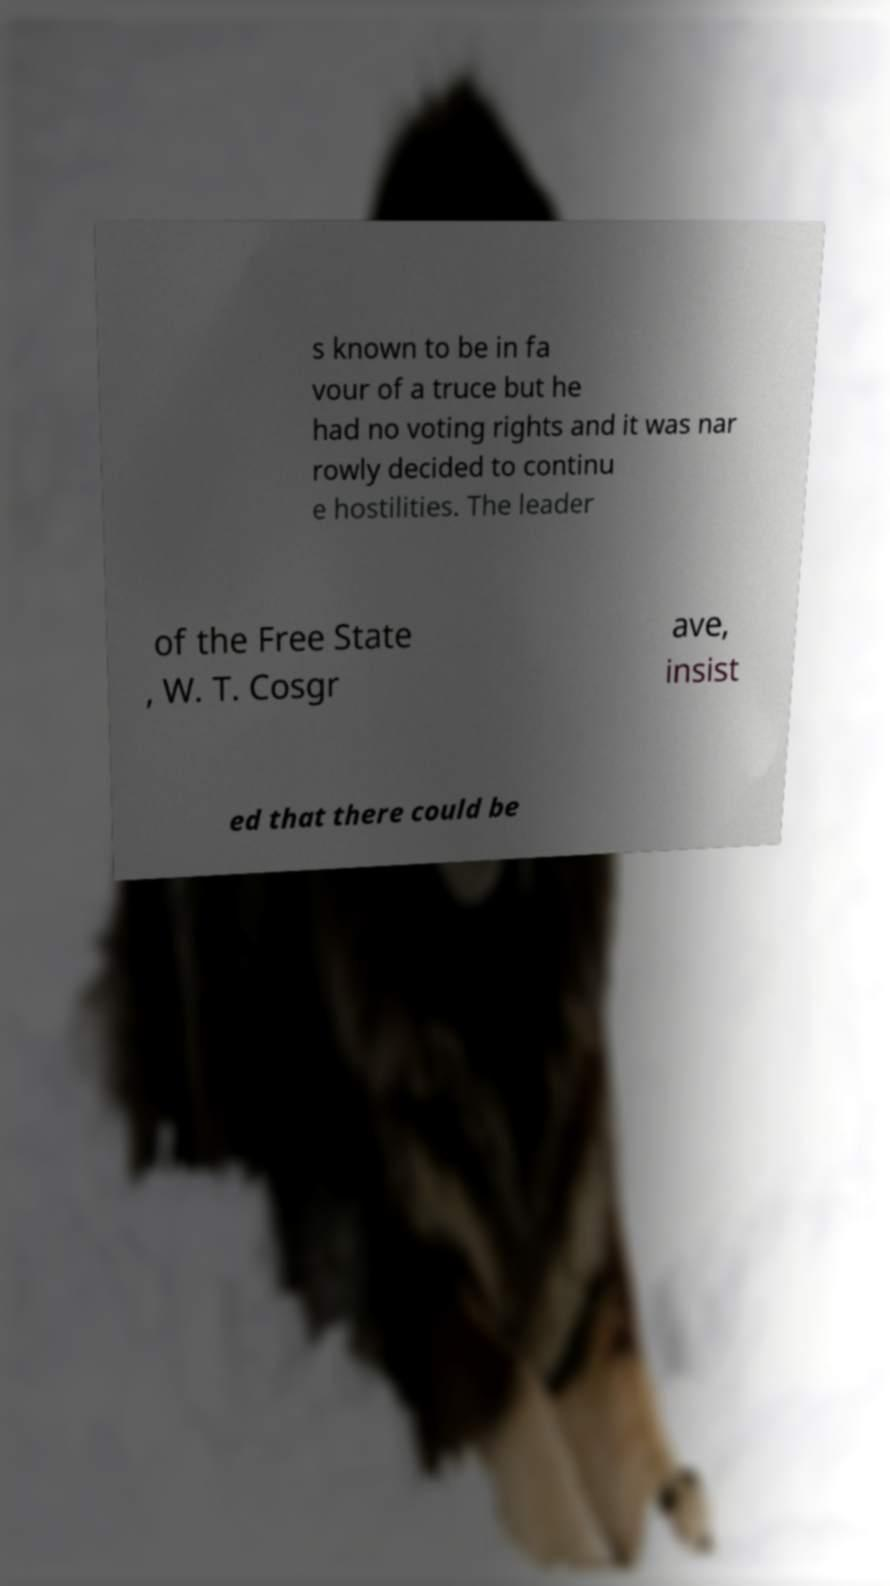Could you assist in decoding the text presented in this image and type it out clearly? s known to be in fa vour of a truce but he had no voting rights and it was nar rowly decided to continu e hostilities. The leader of the Free State , W. T. Cosgr ave, insist ed that there could be 